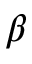Convert formula to latex. <formula><loc_0><loc_0><loc_500><loc_500>\beta</formula> 